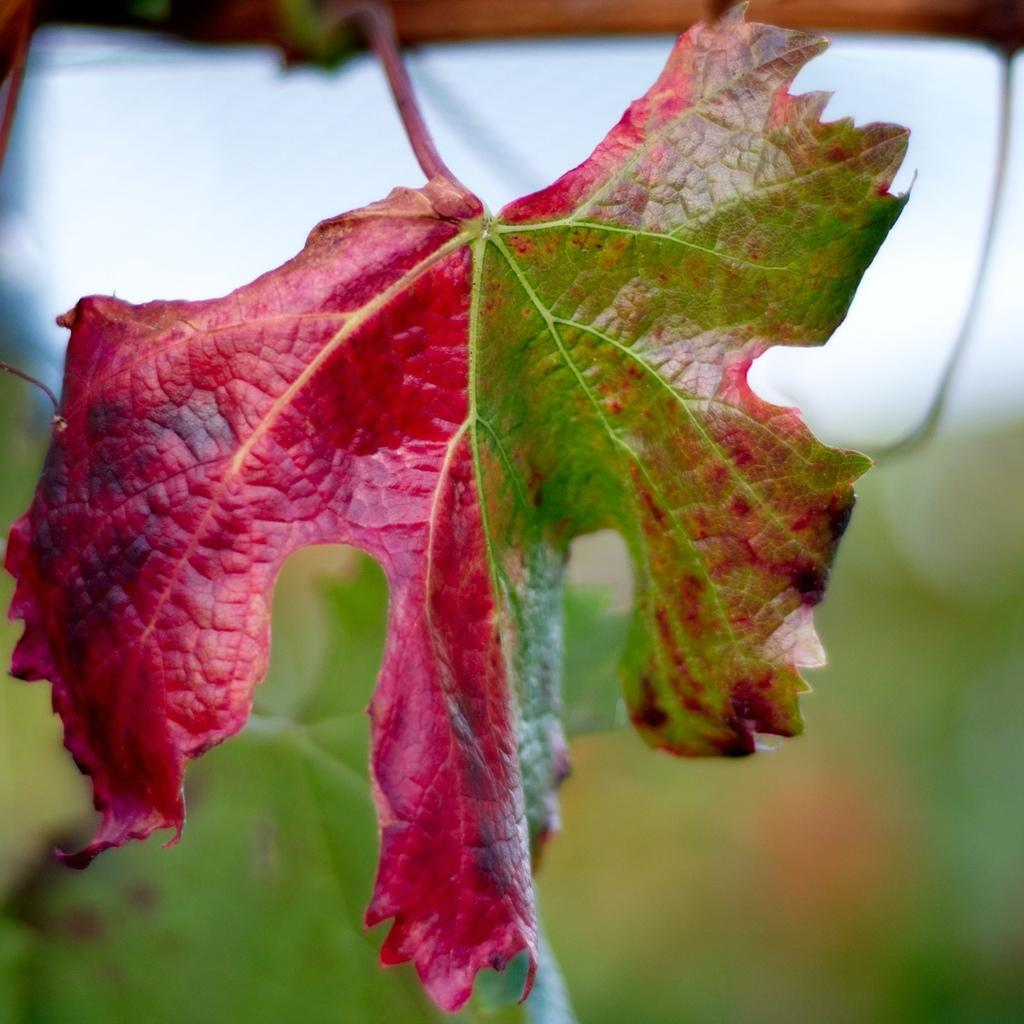What is the main subject of the image? There is a leaf in the center of the image. Can you describe the leaf in more detail? Unfortunately, the image does not provide enough detail to describe the leaf further. What hobbies does the leaf enjoy in the image? Leaves do not have hobbies, as they are inanimate objects. 